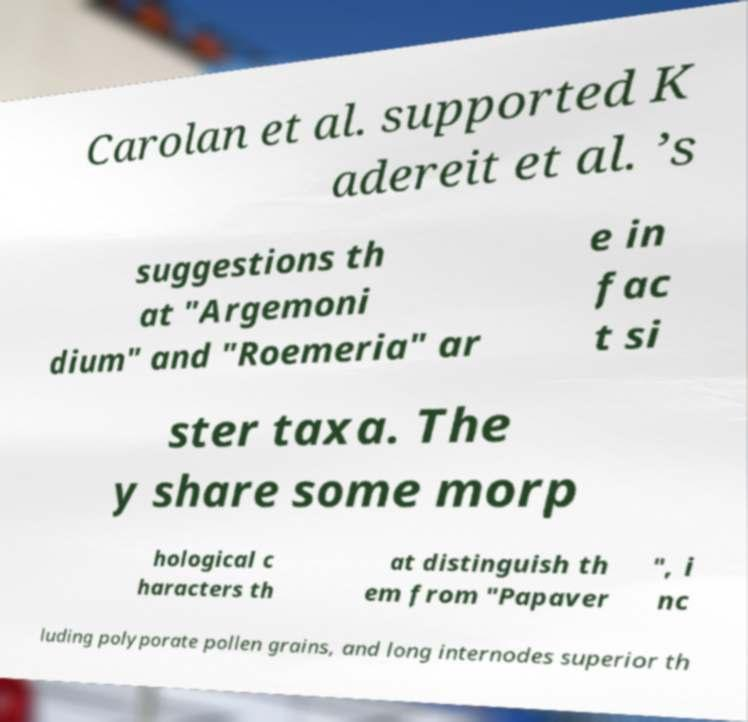Can you read and provide the text displayed in the image?This photo seems to have some interesting text. Can you extract and type it out for me? Carolan et al. supported K adereit et al. ’s suggestions th at "Argemoni dium" and "Roemeria" ar e in fac t si ster taxa. The y share some morp hological c haracters th at distinguish th em from "Papaver ", i nc luding polyporate pollen grains, and long internodes superior th 